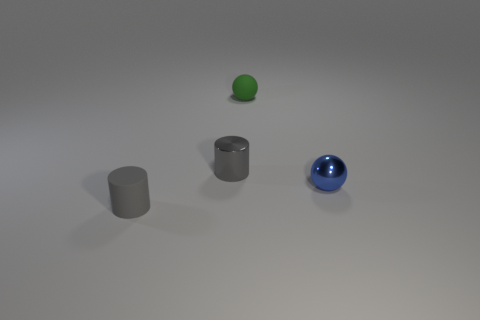There is a tiny green rubber sphere; what number of blue metal things are on the left side of it? 0 